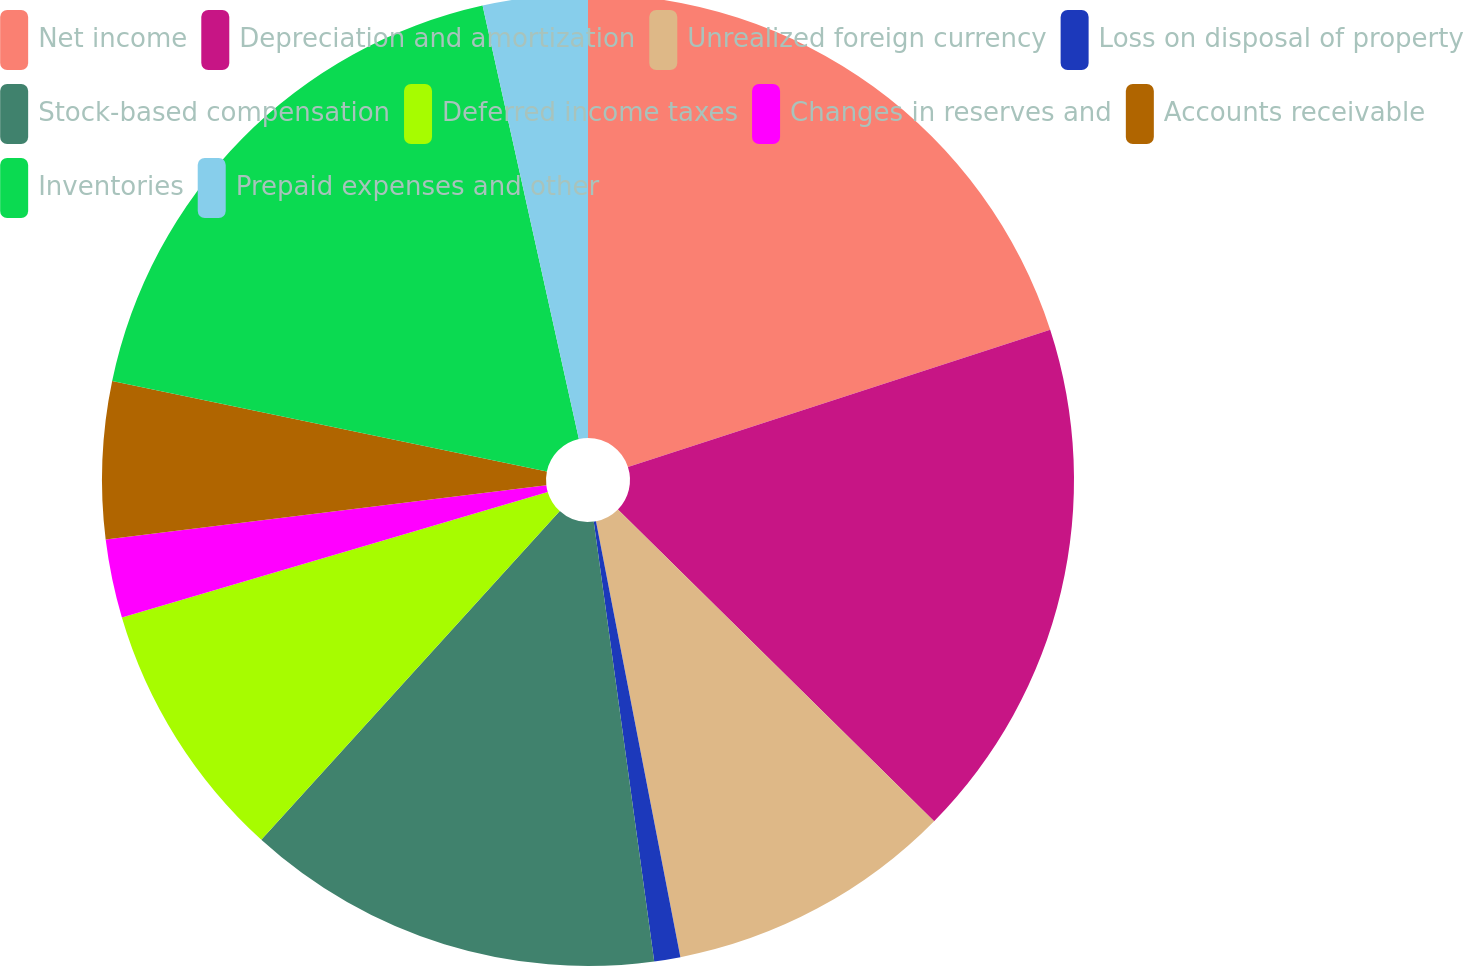Convert chart to OTSL. <chart><loc_0><loc_0><loc_500><loc_500><pie_chart><fcel>Net income<fcel>Depreciation and amortization<fcel>Unrealized foreign currency<fcel>Loss on disposal of property<fcel>Stock-based compensation<fcel>Deferred income taxes<fcel>Changes in reserves and<fcel>Accounts receivable<fcel>Inventories<fcel>Prepaid expenses and other<nl><fcel>20.0%<fcel>17.39%<fcel>9.57%<fcel>0.87%<fcel>13.91%<fcel>8.7%<fcel>2.61%<fcel>5.22%<fcel>18.26%<fcel>3.48%<nl></chart> 